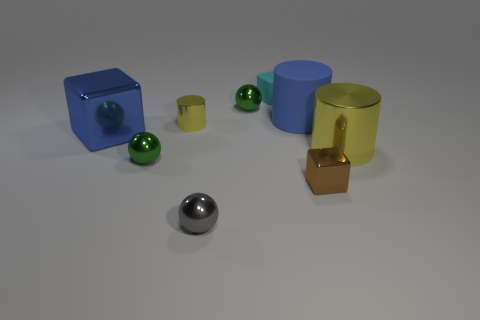Subtract all blocks. How many objects are left? 6 Add 9 tiny gray metallic balls. How many tiny gray metallic balls are left? 10 Add 3 brown metal blocks. How many brown metal blocks exist? 4 Subtract 0 blue spheres. How many objects are left? 9 Subtract all tiny blue metal cylinders. Subtract all big yellow things. How many objects are left? 8 